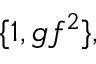<formula> <loc_0><loc_0><loc_500><loc_500>\{ 1 , g f ^ { 2 } \} ,</formula> 